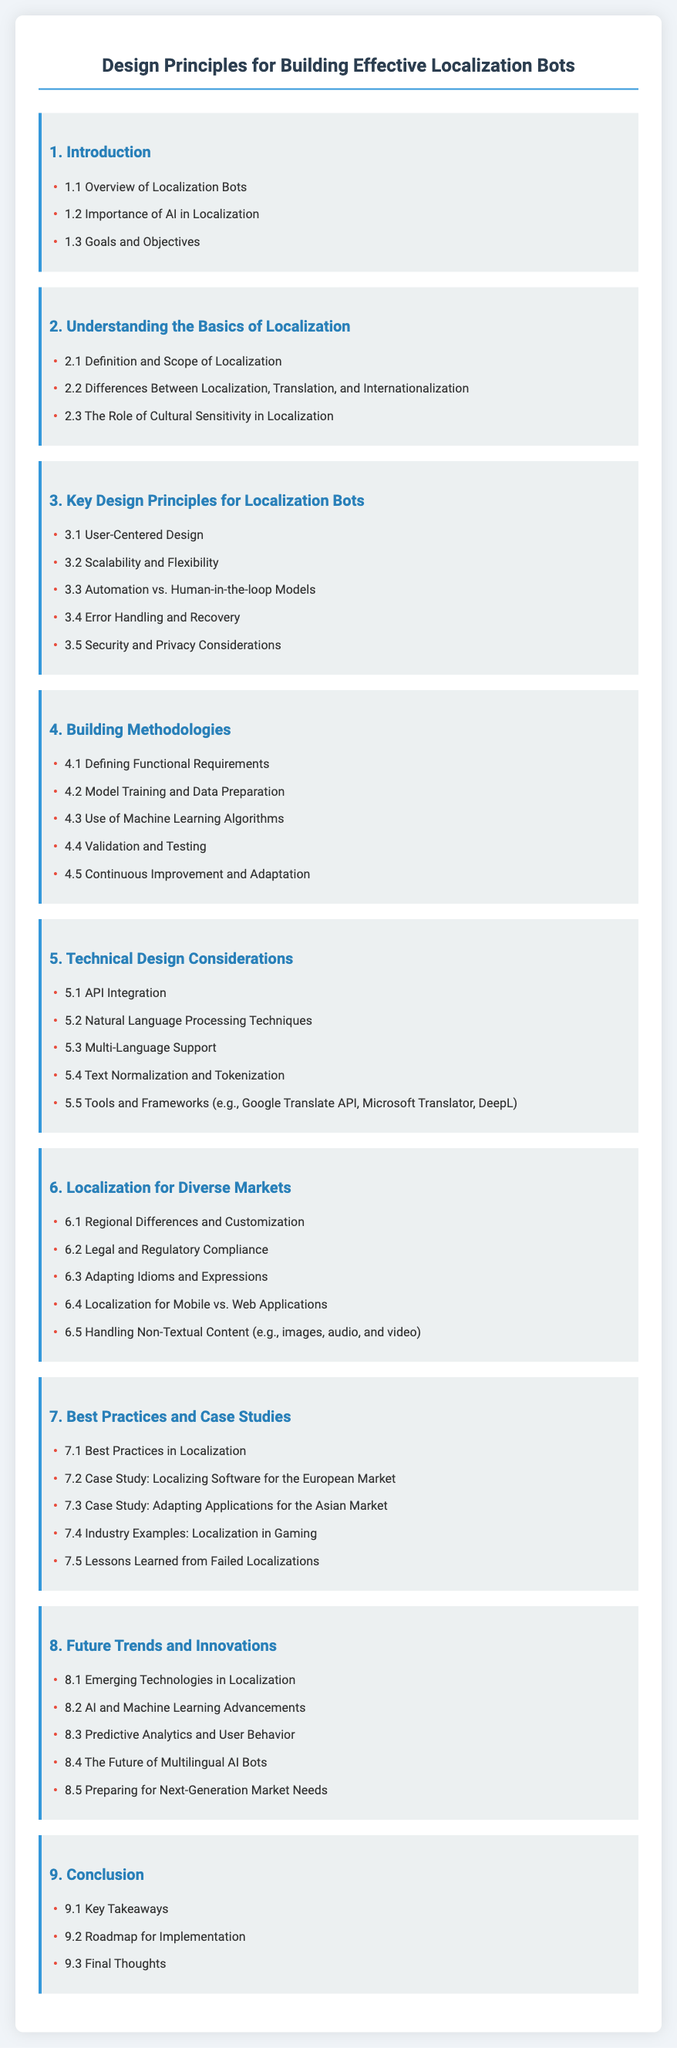what is the title of the document? The title of the document is specified in the header tag as "Design Principles for Building Effective Localization Bots."
Answer: Design Principles for Building Effective Localization Bots how many chapters are there in the document? The number of chapters is counted from the headings listed in the table of contents, totaling nine.
Answer: nine what is the first section of chapter 3? The first section of chapter 3 is identified as "3.1 User-Centered Design."
Answer: 3.1 User-Centered Design which chapter discusses legal and regulatory compliance? Legal and regulatory compliance is addressed in chapter 6, which is titled "Localization for Diverse Markets."
Answer: 6 how many case studies are mentioned in chapter 7? The case studies in chapter 7 are listed in the document, totaling four distinct studies.
Answer: four 